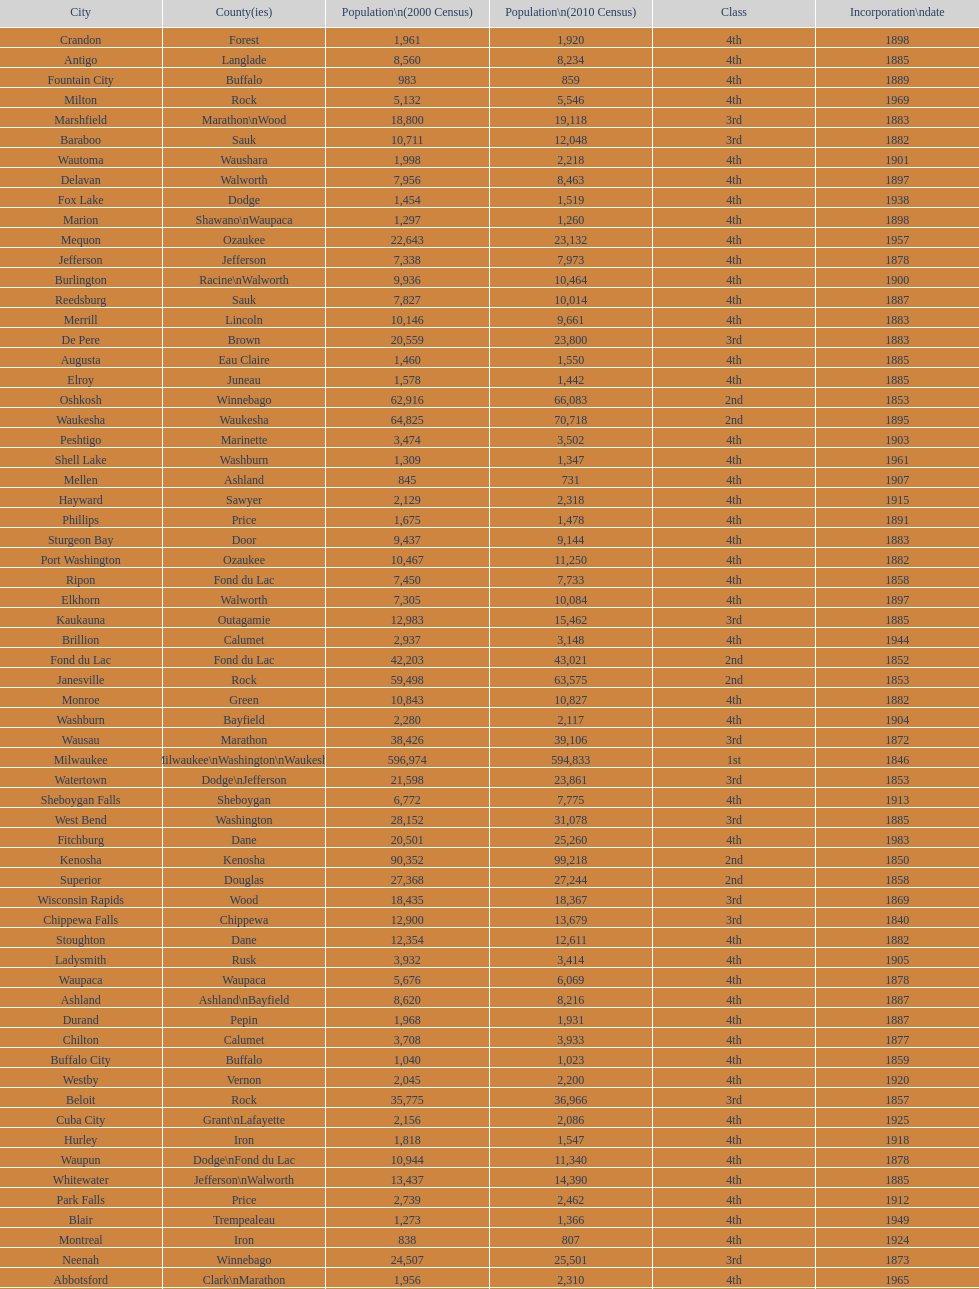How many cities have 1926 as their incorporation date? 2. 